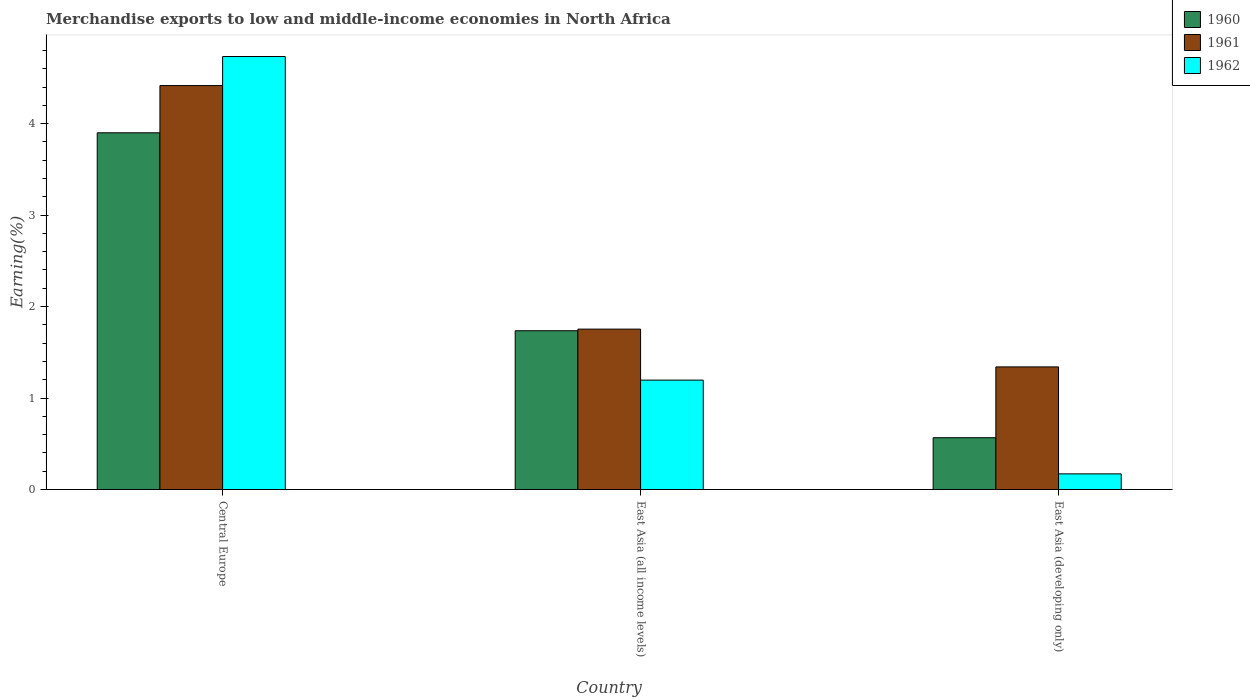How many different coloured bars are there?
Offer a very short reply. 3. How many groups of bars are there?
Ensure brevity in your answer.  3. Are the number of bars per tick equal to the number of legend labels?
Keep it short and to the point. Yes. How many bars are there on the 1st tick from the left?
Your answer should be compact. 3. How many bars are there on the 3rd tick from the right?
Provide a short and direct response. 3. What is the label of the 2nd group of bars from the left?
Ensure brevity in your answer.  East Asia (all income levels). What is the percentage of amount earned from merchandise exports in 1961 in East Asia (developing only)?
Offer a terse response. 1.34. Across all countries, what is the maximum percentage of amount earned from merchandise exports in 1960?
Provide a short and direct response. 3.9. Across all countries, what is the minimum percentage of amount earned from merchandise exports in 1962?
Your answer should be compact. 0.17. In which country was the percentage of amount earned from merchandise exports in 1962 maximum?
Make the answer very short. Central Europe. In which country was the percentage of amount earned from merchandise exports in 1960 minimum?
Make the answer very short. East Asia (developing only). What is the total percentage of amount earned from merchandise exports in 1961 in the graph?
Keep it short and to the point. 7.51. What is the difference between the percentage of amount earned from merchandise exports in 1962 in Central Europe and that in East Asia (developing only)?
Give a very brief answer. 4.56. What is the difference between the percentage of amount earned from merchandise exports in 1961 in East Asia (developing only) and the percentage of amount earned from merchandise exports in 1962 in Central Europe?
Provide a short and direct response. -3.39. What is the average percentage of amount earned from merchandise exports in 1961 per country?
Ensure brevity in your answer.  2.5. What is the difference between the percentage of amount earned from merchandise exports of/in 1962 and percentage of amount earned from merchandise exports of/in 1961 in East Asia (developing only)?
Offer a terse response. -1.17. In how many countries, is the percentage of amount earned from merchandise exports in 1960 greater than 4 %?
Offer a very short reply. 0. What is the ratio of the percentage of amount earned from merchandise exports in 1962 in Central Europe to that in East Asia (all income levels)?
Offer a terse response. 3.96. Is the difference between the percentage of amount earned from merchandise exports in 1962 in Central Europe and East Asia (developing only) greater than the difference between the percentage of amount earned from merchandise exports in 1961 in Central Europe and East Asia (developing only)?
Give a very brief answer. Yes. What is the difference between the highest and the second highest percentage of amount earned from merchandise exports in 1961?
Provide a succinct answer. -2.66. What is the difference between the highest and the lowest percentage of amount earned from merchandise exports in 1962?
Make the answer very short. 4.56. Is the sum of the percentage of amount earned from merchandise exports in 1961 in Central Europe and East Asia (developing only) greater than the maximum percentage of amount earned from merchandise exports in 1960 across all countries?
Offer a very short reply. Yes. What does the 1st bar from the left in East Asia (developing only) represents?
Your answer should be very brief. 1960. What does the 3rd bar from the right in East Asia (all income levels) represents?
Ensure brevity in your answer.  1960. Is it the case that in every country, the sum of the percentage of amount earned from merchandise exports in 1961 and percentage of amount earned from merchandise exports in 1962 is greater than the percentage of amount earned from merchandise exports in 1960?
Ensure brevity in your answer.  Yes. How many bars are there?
Provide a short and direct response. 9. How many countries are there in the graph?
Give a very brief answer. 3. Are the values on the major ticks of Y-axis written in scientific E-notation?
Offer a terse response. No. Does the graph contain grids?
Make the answer very short. No. How are the legend labels stacked?
Offer a terse response. Vertical. What is the title of the graph?
Provide a short and direct response. Merchandise exports to low and middle-income economies in North Africa. What is the label or title of the X-axis?
Your response must be concise. Country. What is the label or title of the Y-axis?
Keep it short and to the point. Earning(%). What is the Earning(%) in 1960 in Central Europe?
Your response must be concise. 3.9. What is the Earning(%) in 1961 in Central Europe?
Your response must be concise. 4.42. What is the Earning(%) of 1962 in Central Europe?
Your answer should be very brief. 4.73. What is the Earning(%) in 1960 in East Asia (all income levels)?
Make the answer very short. 1.74. What is the Earning(%) of 1961 in East Asia (all income levels)?
Give a very brief answer. 1.75. What is the Earning(%) of 1962 in East Asia (all income levels)?
Make the answer very short. 1.2. What is the Earning(%) of 1960 in East Asia (developing only)?
Your answer should be very brief. 0.57. What is the Earning(%) of 1961 in East Asia (developing only)?
Provide a succinct answer. 1.34. What is the Earning(%) in 1962 in East Asia (developing only)?
Your response must be concise. 0.17. Across all countries, what is the maximum Earning(%) of 1960?
Your answer should be compact. 3.9. Across all countries, what is the maximum Earning(%) in 1961?
Ensure brevity in your answer.  4.42. Across all countries, what is the maximum Earning(%) in 1962?
Keep it short and to the point. 4.73. Across all countries, what is the minimum Earning(%) in 1960?
Offer a very short reply. 0.57. Across all countries, what is the minimum Earning(%) of 1961?
Keep it short and to the point. 1.34. Across all countries, what is the minimum Earning(%) in 1962?
Provide a succinct answer. 0.17. What is the total Earning(%) in 1960 in the graph?
Offer a very short reply. 6.2. What is the total Earning(%) in 1961 in the graph?
Your answer should be compact. 7.51. What is the total Earning(%) in 1962 in the graph?
Provide a succinct answer. 6.1. What is the difference between the Earning(%) of 1960 in Central Europe and that in East Asia (all income levels)?
Provide a short and direct response. 2.16. What is the difference between the Earning(%) in 1961 in Central Europe and that in East Asia (all income levels)?
Offer a terse response. 2.66. What is the difference between the Earning(%) of 1962 in Central Europe and that in East Asia (all income levels)?
Your answer should be very brief. 3.54. What is the difference between the Earning(%) of 1960 in Central Europe and that in East Asia (developing only)?
Provide a succinct answer. 3.33. What is the difference between the Earning(%) of 1961 in Central Europe and that in East Asia (developing only)?
Make the answer very short. 3.08. What is the difference between the Earning(%) of 1962 in Central Europe and that in East Asia (developing only)?
Make the answer very short. 4.56. What is the difference between the Earning(%) of 1960 in East Asia (all income levels) and that in East Asia (developing only)?
Your response must be concise. 1.17. What is the difference between the Earning(%) of 1961 in East Asia (all income levels) and that in East Asia (developing only)?
Your answer should be very brief. 0.41. What is the difference between the Earning(%) of 1962 in East Asia (all income levels) and that in East Asia (developing only)?
Keep it short and to the point. 1.02. What is the difference between the Earning(%) of 1960 in Central Europe and the Earning(%) of 1961 in East Asia (all income levels)?
Give a very brief answer. 2.15. What is the difference between the Earning(%) in 1960 in Central Europe and the Earning(%) in 1962 in East Asia (all income levels)?
Offer a terse response. 2.7. What is the difference between the Earning(%) in 1961 in Central Europe and the Earning(%) in 1962 in East Asia (all income levels)?
Offer a very short reply. 3.22. What is the difference between the Earning(%) in 1960 in Central Europe and the Earning(%) in 1961 in East Asia (developing only)?
Keep it short and to the point. 2.56. What is the difference between the Earning(%) in 1960 in Central Europe and the Earning(%) in 1962 in East Asia (developing only)?
Your answer should be very brief. 3.73. What is the difference between the Earning(%) in 1961 in Central Europe and the Earning(%) in 1962 in East Asia (developing only)?
Provide a short and direct response. 4.24. What is the difference between the Earning(%) in 1960 in East Asia (all income levels) and the Earning(%) in 1961 in East Asia (developing only)?
Keep it short and to the point. 0.4. What is the difference between the Earning(%) in 1960 in East Asia (all income levels) and the Earning(%) in 1962 in East Asia (developing only)?
Offer a terse response. 1.56. What is the difference between the Earning(%) in 1961 in East Asia (all income levels) and the Earning(%) in 1962 in East Asia (developing only)?
Ensure brevity in your answer.  1.58. What is the average Earning(%) in 1960 per country?
Give a very brief answer. 2.07. What is the average Earning(%) in 1961 per country?
Offer a very short reply. 2.5. What is the average Earning(%) of 1962 per country?
Offer a very short reply. 2.03. What is the difference between the Earning(%) of 1960 and Earning(%) of 1961 in Central Europe?
Your answer should be compact. -0.52. What is the difference between the Earning(%) in 1960 and Earning(%) in 1962 in Central Europe?
Offer a very short reply. -0.83. What is the difference between the Earning(%) in 1961 and Earning(%) in 1962 in Central Europe?
Your response must be concise. -0.32. What is the difference between the Earning(%) in 1960 and Earning(%) in 1961 in East Asia (all income levels)?
Make the answer very short. -0.02. What is the difference between the Earning(%) of 1960 and Earning(%) of 1962 in East Asia (all income levels)?
Keep it short and to the point. 0.54. What is the difference between the Earning(%) in 1961 and Earning(%) in 1962 in East Asia (all income levels)?
Your answer should be compact. 0.56. What is the difference between the Earning(%) in 1960 and Earning(%) in 1961 in East Asia (developing only)?
Your answer should be very brief. -0.77. What is the difference between the Earning(%) of 1960 and Earning(%) of 1962 in East Asia (developing only)?
Your response must be concise. 0.4. What is the difference between the Earning(%) of 1961 and Earning(%) of 1962 in East Asia (developing only)?
Give a very brief answer. 1.17. What is the ratio of the Earning(%) of 1960 in Central Europe to that in East Asia (all income levels)?
Provide a short and direct response. 2.25. What is the ratio of the Earning(%) in 1961 in Central Europe to that in East Asia (all income levels)?
Keep it short and to the point. 2.52. What is the ratio of the Earning(%) in 1962 in Central Europe to that in East Asia (all income levels)?
Your response must be concise. 3.96. What is the ratio of the Earning(%) of 1960 in Central Europe to that in East Asia (developing only)?
Ensure brevity in your answer.  6.89. What is the ratio of the Earning(%) in 1961 in Central Europe to that in East Asia (developing only)?
Ensure brevity in your answer.  3.29. What is the ratio of the Earning(%) of 1962 in Central Europe to that in East Asia (developing only)?
Your response must be concise. 27.66. What is the ratio of the Earning(%) of 1960 in East Asia (all income levels) to that in East Asia (developing only)?
Your answer should be compact. 3.06. What is the ratio of the Earning(%) of 1961 in East Asia (all income levels) to that in East Asia (developing only)?
Offer a terse response. 1.31. What is the ratio of the Earning(%) of 1962 in East Asia (all income levels) to that in East Asia (developing only)?
Ensure brevity in your answer.  6.99. What is the difference between the highest and the second highest Earning(%) in 1960?
Offer a terse response. 2.16. What is the difference between the highest and the second highest Earning(%) of 1961?
Your answer should be compact. 2.66. What is the difference between the highest and the second highest Earning(%) of 1962?
Ensure brevity in your answer.  3.54. What is the difference between the highest and the lowest Earning(%) of 1960?
Provide a short and direct response. 3.33. What is the difference between the highest and the lowest Earning(%) of 1961?
Offer a very short reply. 3.08. What is the difference between the highest and the lowest Earning(%) in 1962?
Your response must be concise. 4.56. 